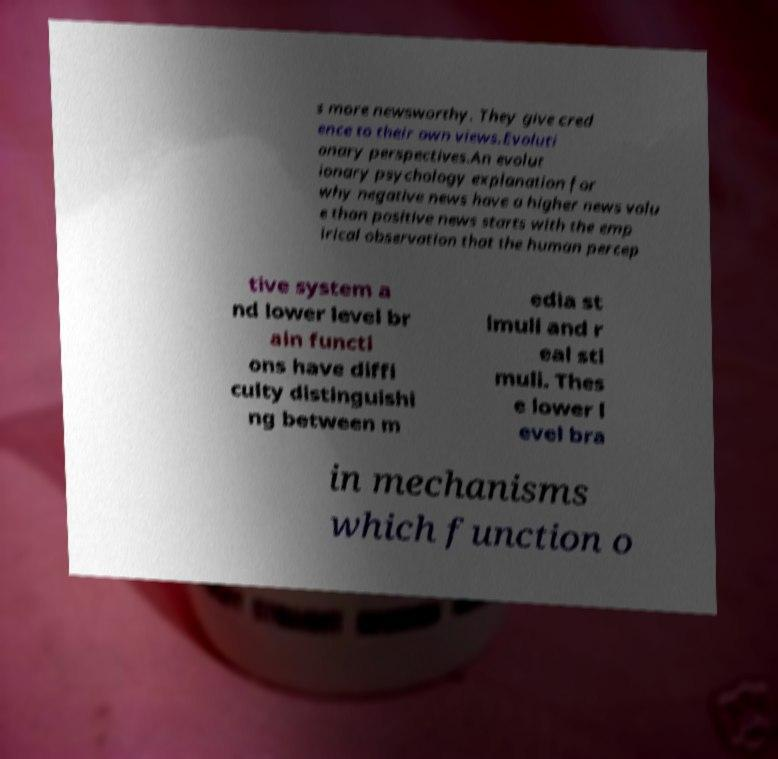Could you assist in decoding the text presented in this image and type it out clearly? s more newsworthy. They give cred ence to their own views.Evoluti onary perspectives.An evolut ionary psychology explanation for why negative news have a higher news valu e than positive news starts with the emp irical observation that the human percep tive system a nd lower level br ain functi ons have diffi culty distinguishi ng between m edia st imuli and r eal sti muli. Thes e lower l evel bra in mechanisms which function o 